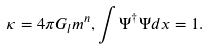Convert formula to latex. <formula><loc_0><loc_0><loc_500><loc_500>\kappa = 4 \pi G _ { l } m ^ { n } , \int \Psi ^ { \dag } \Psi d { x } = 1 .</formula> 